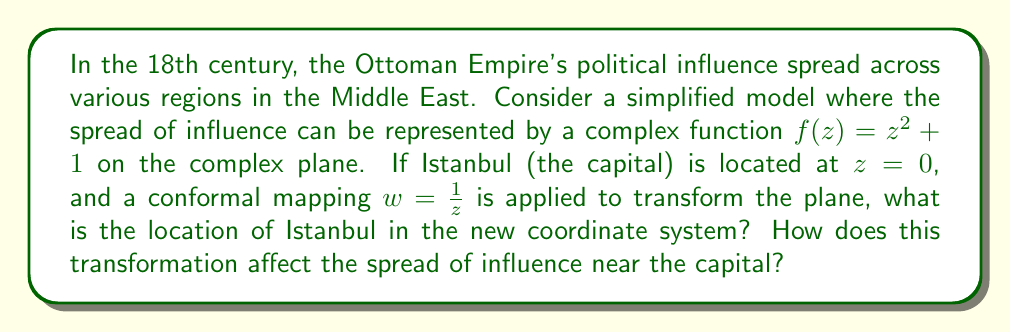Teach me how to tackle this problem. To solve this problem, we need to follow these steps:

1) The original location of Istanbul is at $z = 0$ in the complex plane.

2) We are given a conformal mapping $w = \frac{1}{z}$. This is known as the inversion map.

3) To find the new location of Istanbul, we need to apply this mapping to $z = 0$. However, we immediately encounter a problem: $\frac{1}{0}$ is undefined.

4) In complex analysis, we can consider the point at infinity. The inversion map sends 0 to infinity and infinity to 0. Therefore, in the new coordinate system, Istanbul is located at infinity.

5) To understand how this affects the spread of influence, let's consider the original influence function $f(z) = z^2 + 1$.

6) Near $z = 0$ (Istanbul), we can approximate this function using its Taylor series:
   
   $f(z) \approx f(0) + f'(0)z + \frac{f''(0)}{2!}z^2 + ... = 1 + 0z + z^2 = 1 + z^2$

7) This shows that near Istanbul, the influence spreads quadratically.

8) After the conformal mapping, points near 0 are mapped to points near infinity. To see how the influence spreads near infinity in the new system, we can compose $f$ with the inverse of our conformal mapping:

   $f(\frac{1}{w}) = (\frac{1}{w})^2 + 1 = \frac{1}{w^2} + 1$

9) As $w$ approaches infinity (near the new location of Istanbul), this function approaches 1.

This means that in the new coordinate system, the spread of influence becomes nearly constant near Istanbul (which is now at infinity), contrasting with the quadratic spread in the original system.
Answer: In the new coordinate system, Istanbul is located at infinity. The transformation changes the spread of influence from quadratic near the capital in the original system to nearly constant near the capital in the new system. 